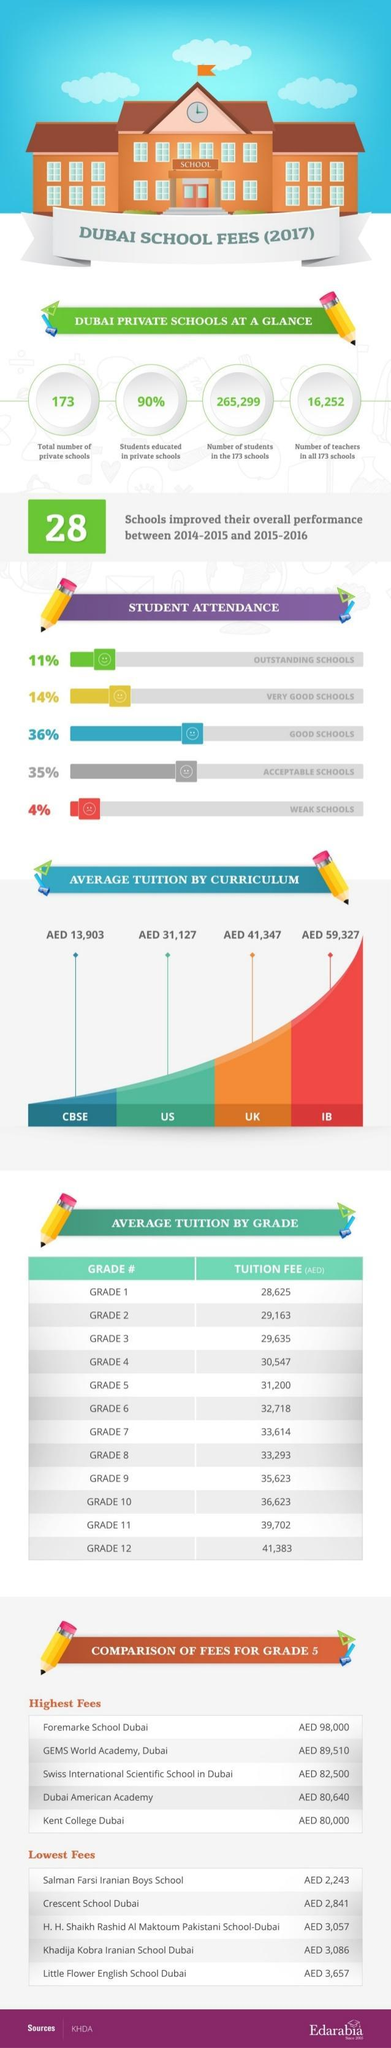Which type of school has second highest student attendance?
Answer the question with a short phrase. ACCEPTABLE SCHOOLS How many schools in Dubai has been listed in the highest fees category? 5 Which school has second highest fees for grade 5 in Dubai? GEMS World Academy, Dubai Which school has second lowest fees for grade 5 in Dubai? Crescent School Dubai What is the average tuition fee of UK curriculum? AED 41,347 What is the total no of students studying in private schools? 265,299 For how many grades tuition fee is more than 30,000? 9 What is the no of teachers in private schools? 16,252 What is the inverse of Student attendance for very good schools? 86 What percentage of students education is not from a private school? 10 